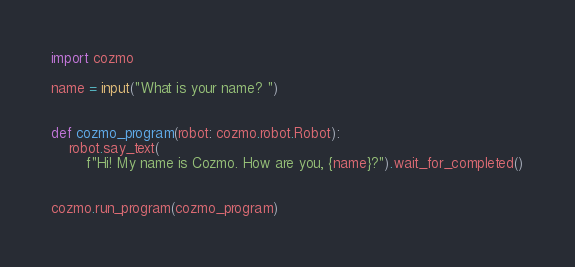<code> <loc_0><loc_0><loc_500><loc_500><_Python_>import cozmo

name = input("What is your name? ")


def cozmo_program(robot: cozmo.robot.Robot):
    robot.say_text(
        f"Hi! My name is Cozmo. How are you, {name}?").wait_for_completed()


cozmo.run_program(cozmo_program)
</code> 